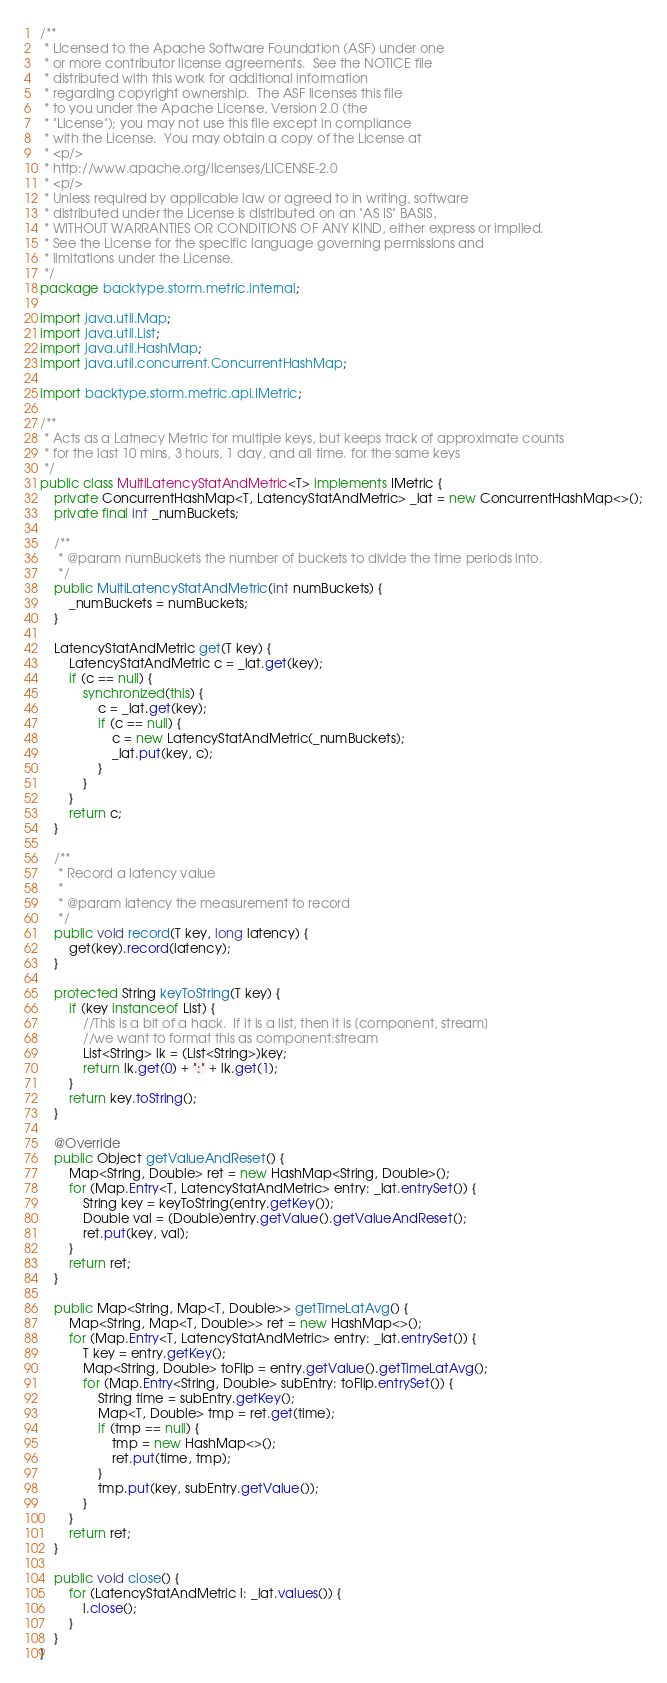<code> <loc_0><loc_0><loc_500><loc_500><_Java_>/**
 * Licensed to the Apache Software Foundation (ASF) under one
 * or more contributor license agreements.  See the NOTICE file
 * distributed with this work for additional information
 * regarding copyright ownership.  The ASF licenses this file
 * to you under the Apache License, Version 2.0 (the
 * "License"); you may not use this file except in compliance
 * with the License.  You may obtain a copy of the License at
 * <p/>
 * http://www.apache.org/licenses/LICENSE-2.0
 * <p/>
 * Unless required by applicable law or agreed to in writing, software
 * distributed under the License is distributed on an "AS IS" BASIS,
 * WITHOUT WARRANTIES OR CONDITIONS OF ANY KIND, either express or implied.
 * See the License for the specific language governing permissions and
 * limitations under the License.
 */
package backtype.storm.metric.internal;

import java.util.Map;
import java.util.List;
import java.util.HashMap;
import java.util.concurrent.ConcurrentHashMap;

import backtype.storm.metric.api.IMetric;

/**
 * Acts as a Latnecy Metric for multiple keys, but keeps track of approximate counts
 * for the last 10 mins, 3 hours, 1 day, and all time. for the same keys
 */
public class MultiLatencyStatAndMetric<T> implements IMetric {
    private ConcurrentHashMap<T, LatencyStatAndMetric> _lat = new ConcurrentHashMap<>();
    private final int _numBuckets;

    /**
     * @param numBuckets the number of buckets to divide the time periods into.
     */
    public MultiLatencyStatAndMetric(int numBuckets) {
        _numBuckets = numBuckets;
    }

    LatencyStatAndMetric get(T key) {
        LatencyStatAndMetric c = _lat.get(key);
        if (c == null) {
            synchronized(this) {
                c = _lat.get(key);
                if (c == null) {
                    c = new LatencyStatAndMetric(_numBuckets);
                    _lat.put(key, c);
                }
            }
        }
        return c;
    }

    /**
     * Record a latency value
     *
     * @param latency the measurement to record
     */
    public void record(T key, long latency) {
        get(key).record(latency);
    }

    protected String keyToString(T key) {
        if (key instanceof List) {
            //This is a bit of a hack.  If it is a list, then it is [component, stream]
            //we want to format this as component:stream
            List<String> lk = (List<String>)key;
            return lk.get(0) + ":" + lk.get(1);
        }
        return key.toString();
    }

    @Override
    public Object getValueAndReset() {
        Map<String, Double> ret = new HashMap<String, Double>();
        for (Map.Entry<T, LatencyStatAndMetric> entry: _lat.entrySet()) {
            String key = keyToString(entry.getKey());
            Double val = (Double)entry.getValue().getValueAndReset();
            ret.put(key, val);
        }
        return ret;
    }

    public Map<String, Map<T, Double>> getTimeLatAvg() {
        Map<String, Map<T, Double>> ret = new HashMap<>();
        for (Map.Entry<T, LatencyStatAndMetric> entry: _lat.entrySet()) {
            T key = entry.getKey();
            Map<String, Double> toFlip = entry.getValue().getTimeLatAvg();
            for (Map.Entry<String, Double> subEntry: toFlip.entrySet()) {
                String time = subEntry.getKey();
                Map<T, Double> tmp = ret.get(time);
                if (tmp == null) {
                    tmp = new HashMap<>();
                    ret.put(time, tmp);
                }
                tmp.put(key, subEntry.getValue());
            }
        }
        return ret;
    }

    public void close() {
        for (LatencyStatAndMetric l: _lat.values()) {
            l.close();
        }
    }
}
</code> 